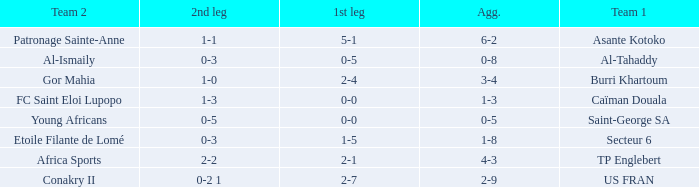Which team lost 0-3 and 0-5? Al-Tahaddy. 